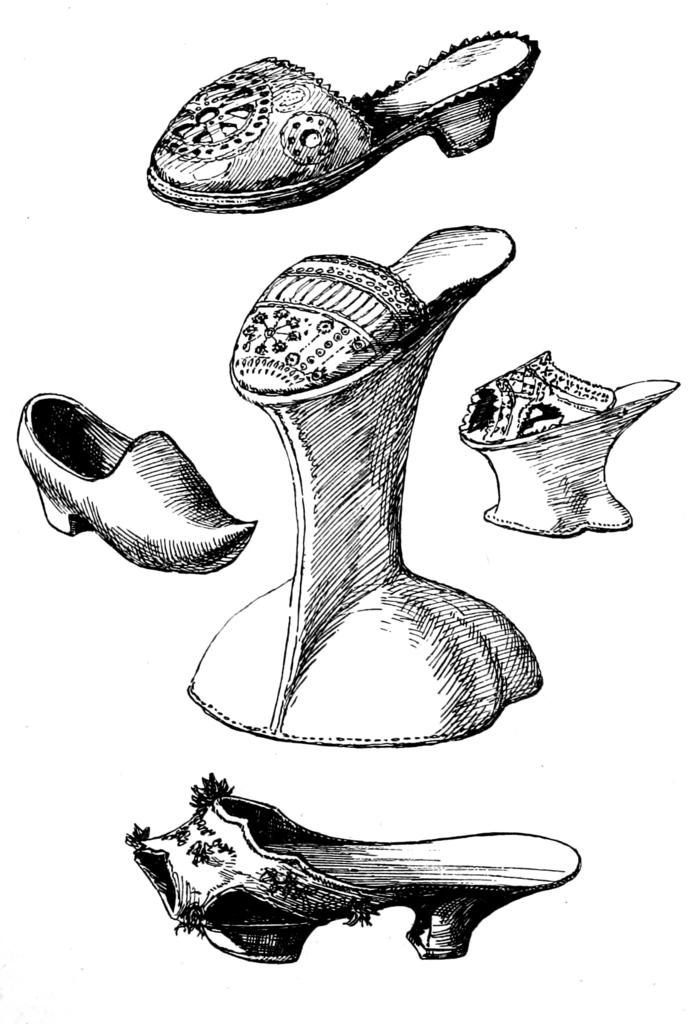What is depicted in the image? The image contains a sketch of footwear. What color is the footwear in the image? The footwear is black in color. How many footwear are shown in the image? There are two footwear in the image. What color is the background of the image? The background of the image is white. Can you see a quill being used to draw the footwear in the image? There is no quill visible in the image, and it is a sketch rather than a drawing made with a quill. Are the footwear in the image exchanging a kiss? There is no indication of any interaction between the footwear in the image, let alone a kiss. 